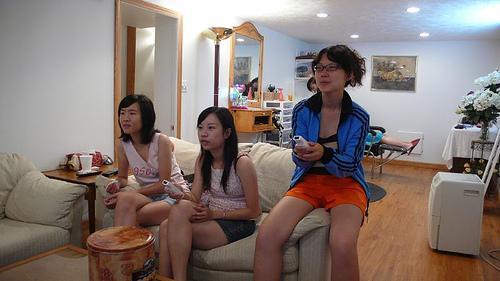How many girls are wearing glasses?
Give a very brief answer. 1. How many people are in the picture?
Give a very brief answer. 3. How many couches are there?
Give a very brief answer. 2. 